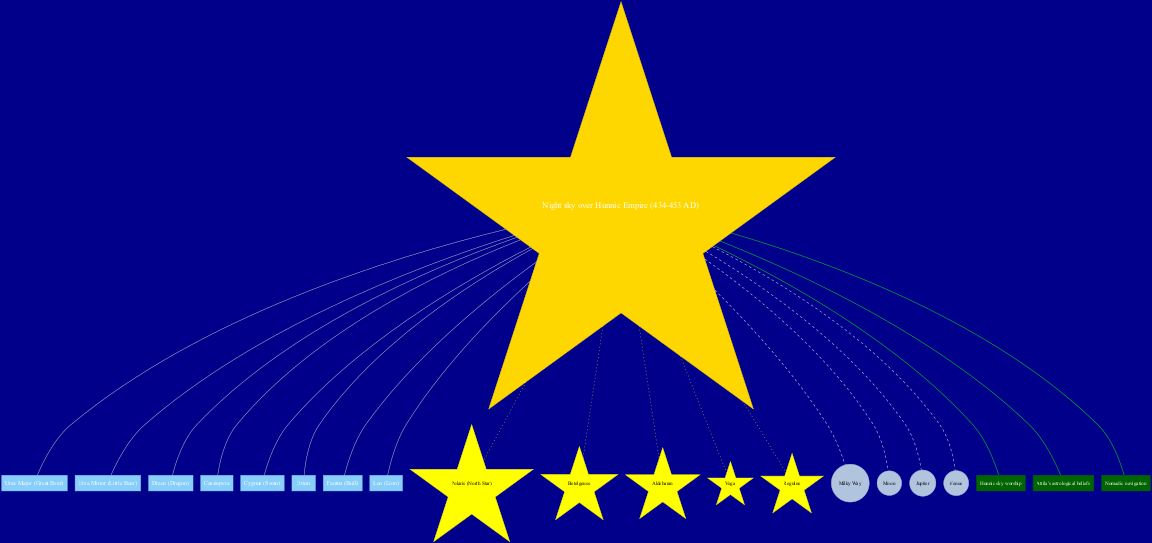What is the central element of the diagram? The diagram has a central node labeled "Night sky over Hunnic Empire (434-453 AD)", which serves as the focal point connecting all other elements.
Answer: Night sky over Hunnic Empire (434-453 AD) How many constellations are shown in the diagram? The diagram lists a total of eight constellations, which can be counted directly from the "constellations" section.
Answer: 8 Which star is represented with the greatest significance? Polaris (North Star) is represented as a central star, implied by its unique label and shape, often denoting importance in navigation and celestial orientation.
Answer: Polaris (North Star) What connects cultural beliefs to celestial objects? The edges connecting cultural connection nodes to the central node indicate a relationship between Hunnic sky worship, Attila's astrological beliefs, and nomadic navigation with the celestial elements in the diagram.
Answer: Hunnic sky worship, Attila's astrological beliefs, nomadic navigation Which constellation is associated with the figure of a swan? The diagram directly identifies the constellation "Cygnus (Swan)", which is clearly labeled among the other constellations.
Answer: Cygnus (Swan) Name one celestial object featured in the diagram. The diagram mentions several celestial objects, including the Moon, which are represented in the celestial object section.
Answer: Moon Which is the brightest star mentioned in the chart? Among the stars listed, Betelgeuse is known for its brightness, and its label indicates prominence in the diagram.
Answer: Betelgeuse How many edges connect stars to the center? Since there are five stars listed in the diagram, and each is connected to the center, there are five edges, one for each star.
Answer: 5 Which cultural connection mentions Attila? The edge labeled "Attila's astrological beliefs" indicates a specific cultural connection to the central theme of the diagram.
Answer: Attila's astrological beliefs 